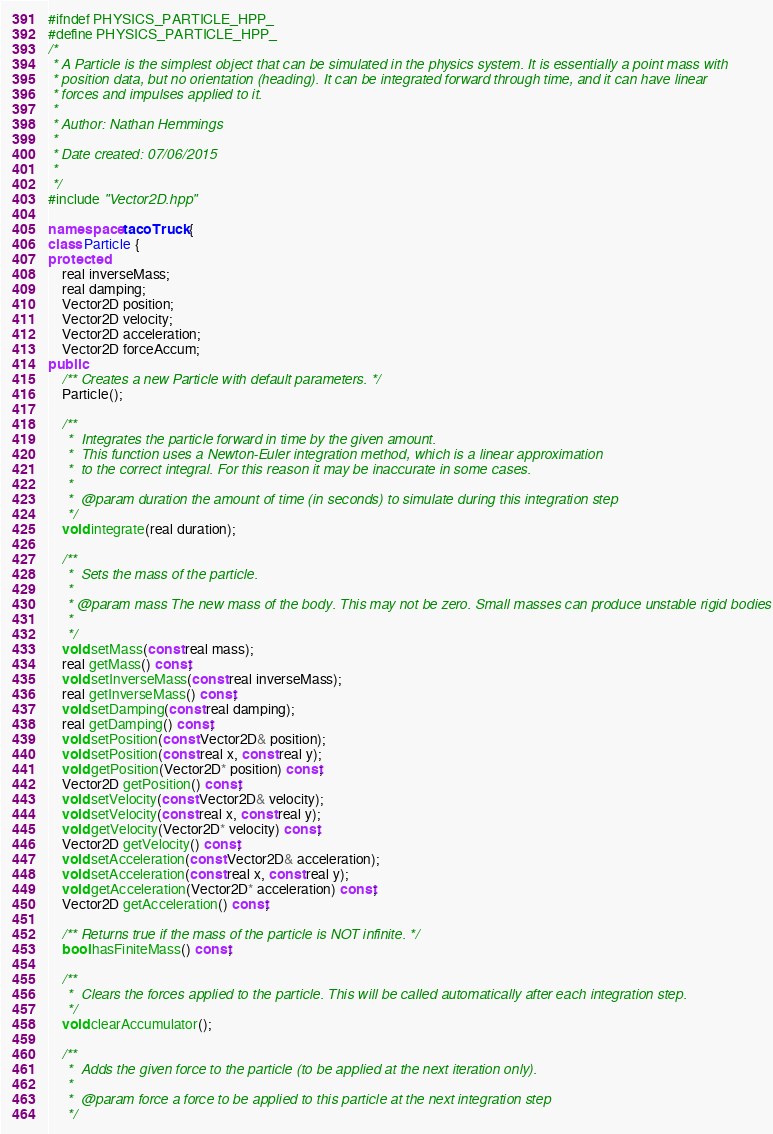Convert code to text. <code><loc_0><loc_0><loc_500><loc_500><_C++_>#ifndef PHYSICS_PARTICLE_HPP_
#define PHYSICS_PARTICLE_HPP_
/*
 * A Particle is the simplest object that can be simulated in the physics system. It is essentially a point mass with
 * position data, but no orientation (heading). It can be integrated forward through time, and it can have linear
 * forces and impulses applied to it.
 *
 * Author: Nathan Hemmings
 *
 * Date created: 07/06/2015
 *
 */
#include "Vector2D.hpp"

namespace tacoTruck {
class Particle {
protected:
    real inverseMass;
    real damping;
    Vector2D position;
    Vector2D velocity;
    Vector2D acceleration;
    Vector2D forceAccum;
public:
    /** Creates a new Particle with default parameters. */
    Particle();

    /**
     *	Integrates the particle forward in time by the given amount.
     *	This function uses a Newton-Euler integration method, which is a linear approximation
     *	to the correct integral. For this reason it may be inaccurate in some cases.
     *
     *  @param duration the amount of time (in seconds) to simulate during this integration step
     */
    void integrate(real duration);

    /**
     *	Sets the mass of the particle.
     *
     * @param mass The new mass of the body. This may not be zero. Small masses can produce unstable rigid bodies
     *
     */
    void setMass(const real mass);
    real getMass() const;
    void setInverseMass(const real inverseMass);
    real getInverseMass() const;
    void setDamping(const real damping);
    real getDamping() const;
    void setPosition(const Vector2D& position);
    void setPosition(const real x, const real y);
    void getPosition(Vector2D* position) const;
    Vector2D getPosition() const;
    void setVelocity(const Vector2D& velocity);
    void setVelocity(const real x, const real y);
    void getVelocity(Vector2D* velocity) const;
    Vector2D getVelocity() const;
    void setAcceleration(const Vector2D& acceleration);
    void setAcceleration(const real x, const real y);
    void getAcceleration(Vector2D* acceleration) const;
    Vector2D getAcceleration() const;

    /** Returns true if the mass of the particle is NOT infinite. */
    bool hasFiniteMass() const;

    /**
     *  Clears the forces applied to the particle. This will be called automatically after each integration step.
     */
    void clearAccumulator();

    /**
     *  Adds the given force to the particle (to be applied at the next iteration only).
     *
     *  @param force a force to be applied to this particle at the next integration step
     */</code> 